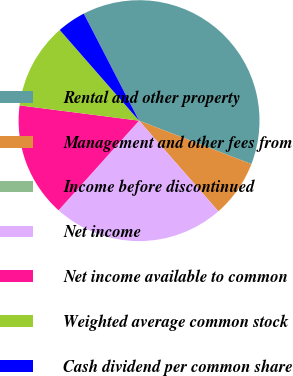Convert chart to OTSL. <chart><loc_0><loc_0><loc_500><loc_500><pie_chart><fcel>Rental and other property<fcel>Management and other fees from<fcel>Income before discontinued<fcel>Net income<fcel>Net income available to common<fcel>Weighted average common stock<fcel>Cash dividend per common share<nl><fcel>38.46%<fcel>7.69%<fcel>0.0%<fcel>23.08%<fcel>15.38%<fcel>11.54%<fcel>3.85%<nl></chart> 